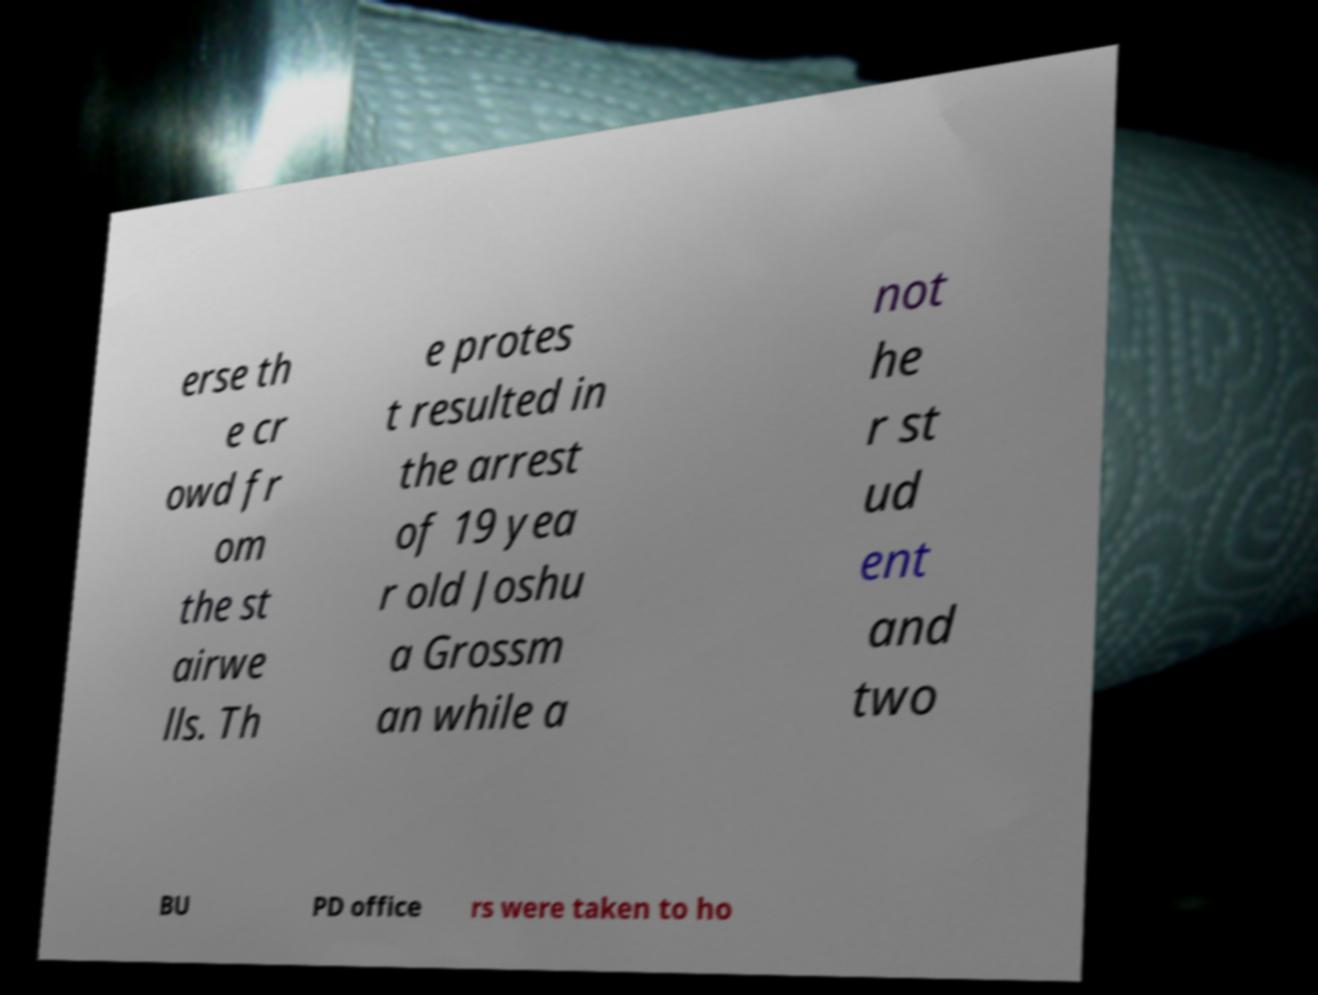I need the written content from this picture converted into text. Can you do that? erse th e cr owd fr om the st airwe lls. Th e protes t resulted in the arrest of 19 yea r old Joshu a Grossm an while a not he r st ud ent and two BU PD office rs were taken to ho 